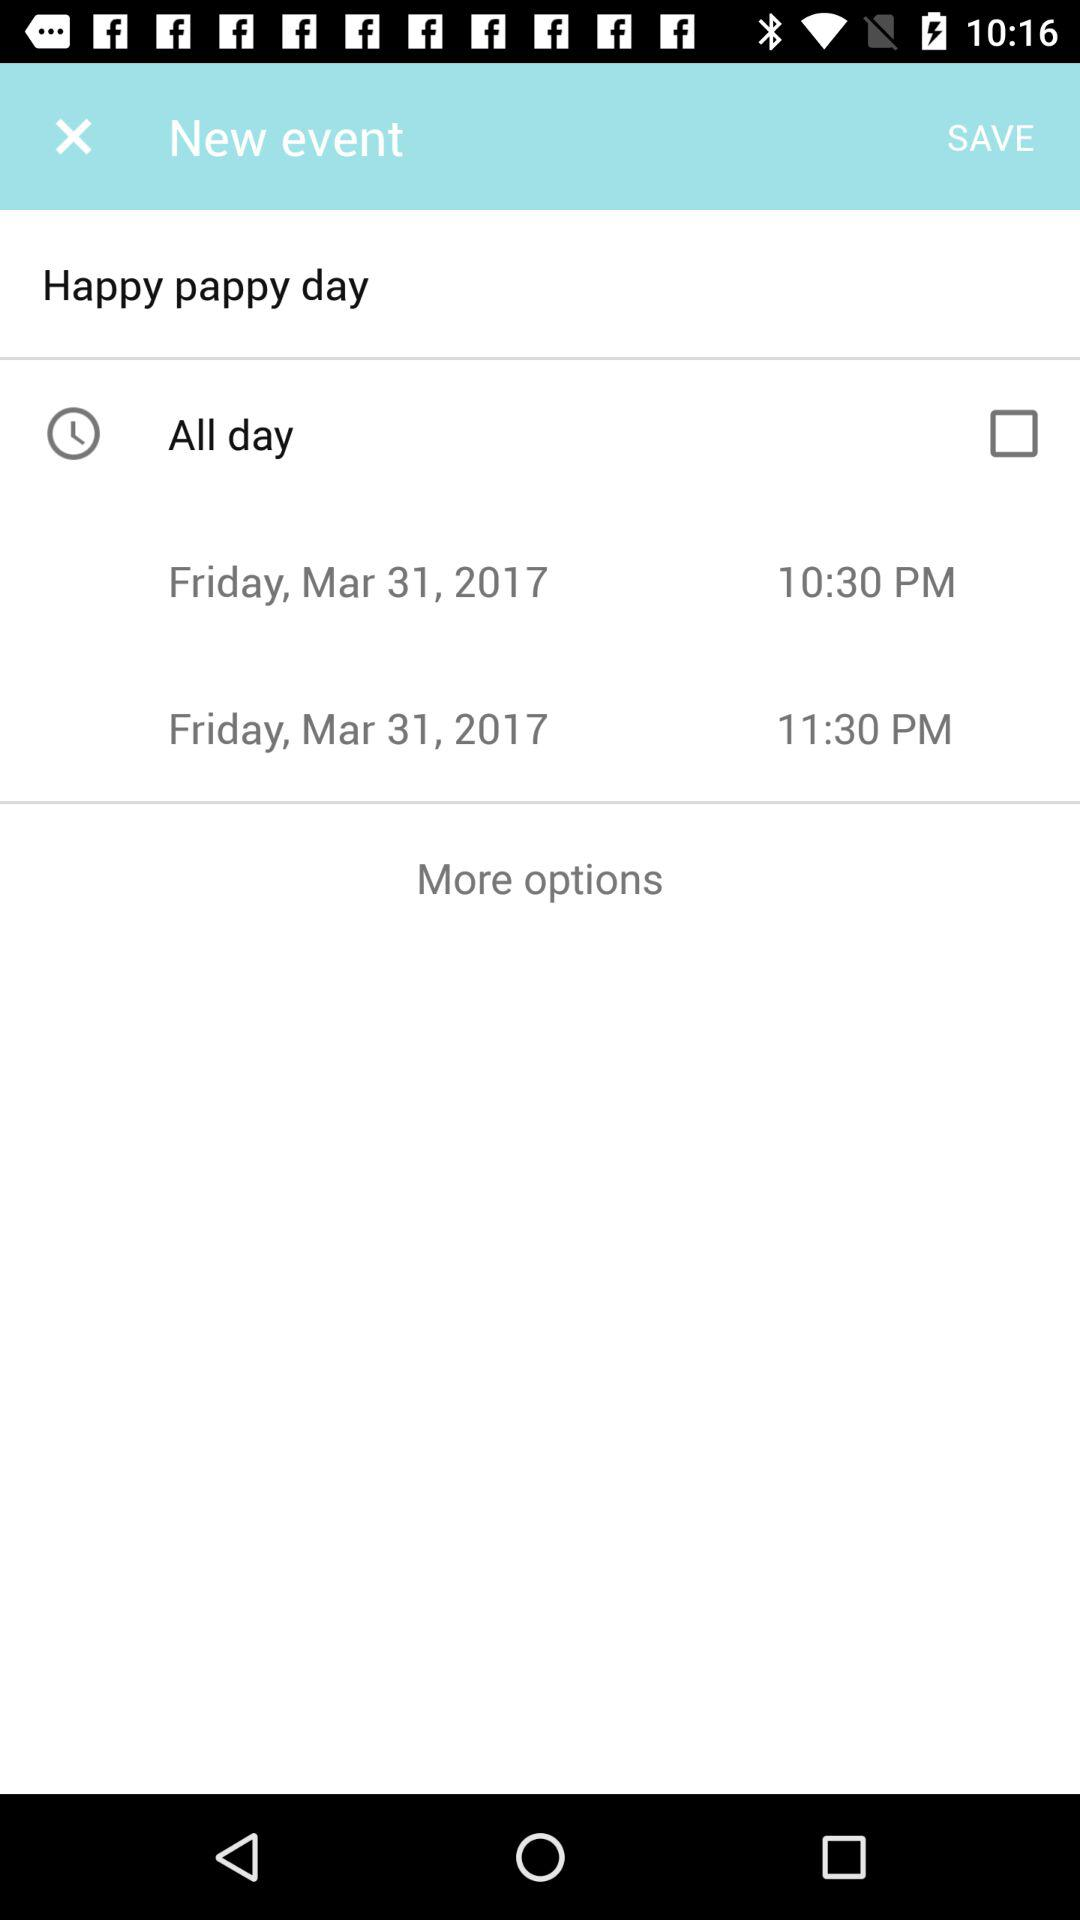What is the date of Happy Pappy's Day? The date of Happy Pappy's Day is Friday, March 31, 2017. 